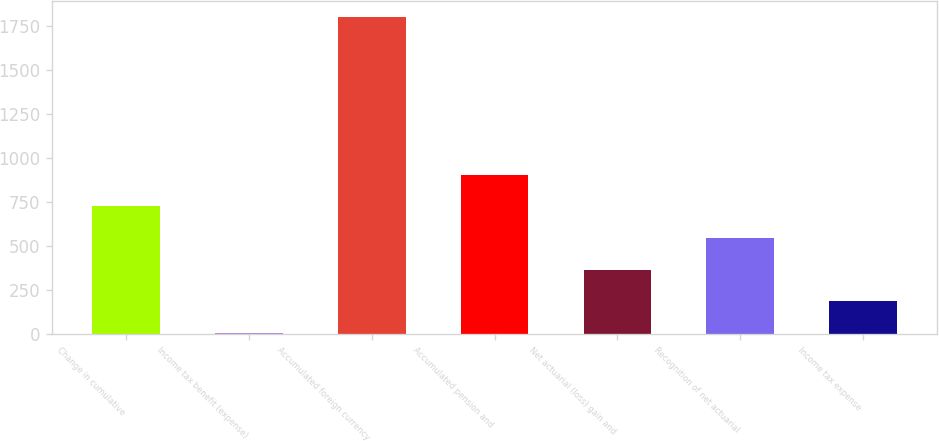Convert chart to OTSL. <chart><loc_0><loc_0><loc_500><loc_500><bar_chart><fcel>Change in cumulative<fcel>Income tax benefit (expense)<fcel>Accumulated foreign currency<fcel>Accumulated pension and<fcel>Net actuarial (loss) gain and<fcel>Recognition of net actuarial<fcel>Income tax expense<nl><fcel>726.2<fcel>9<fcel>1802<fcel>905.5<fcel>367.6<fcel>546.9<fcel>188.3<nl></chart> 